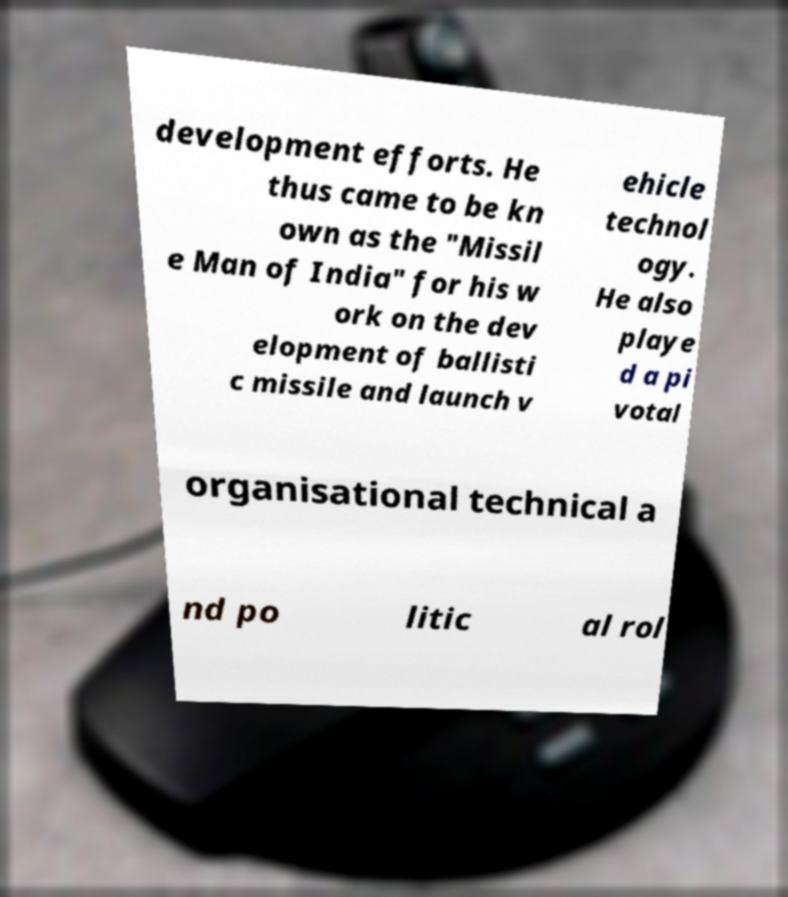Please read and relay the text visible in this image. What does it say? development efforts. He thus came to be kn own as the "Missil e Man of India" for his w ork on the dev elopment of ballisti c missile and launch v ehicle technol ogy. He also playe d a pi votal organisational technical a nd po litic al rol 